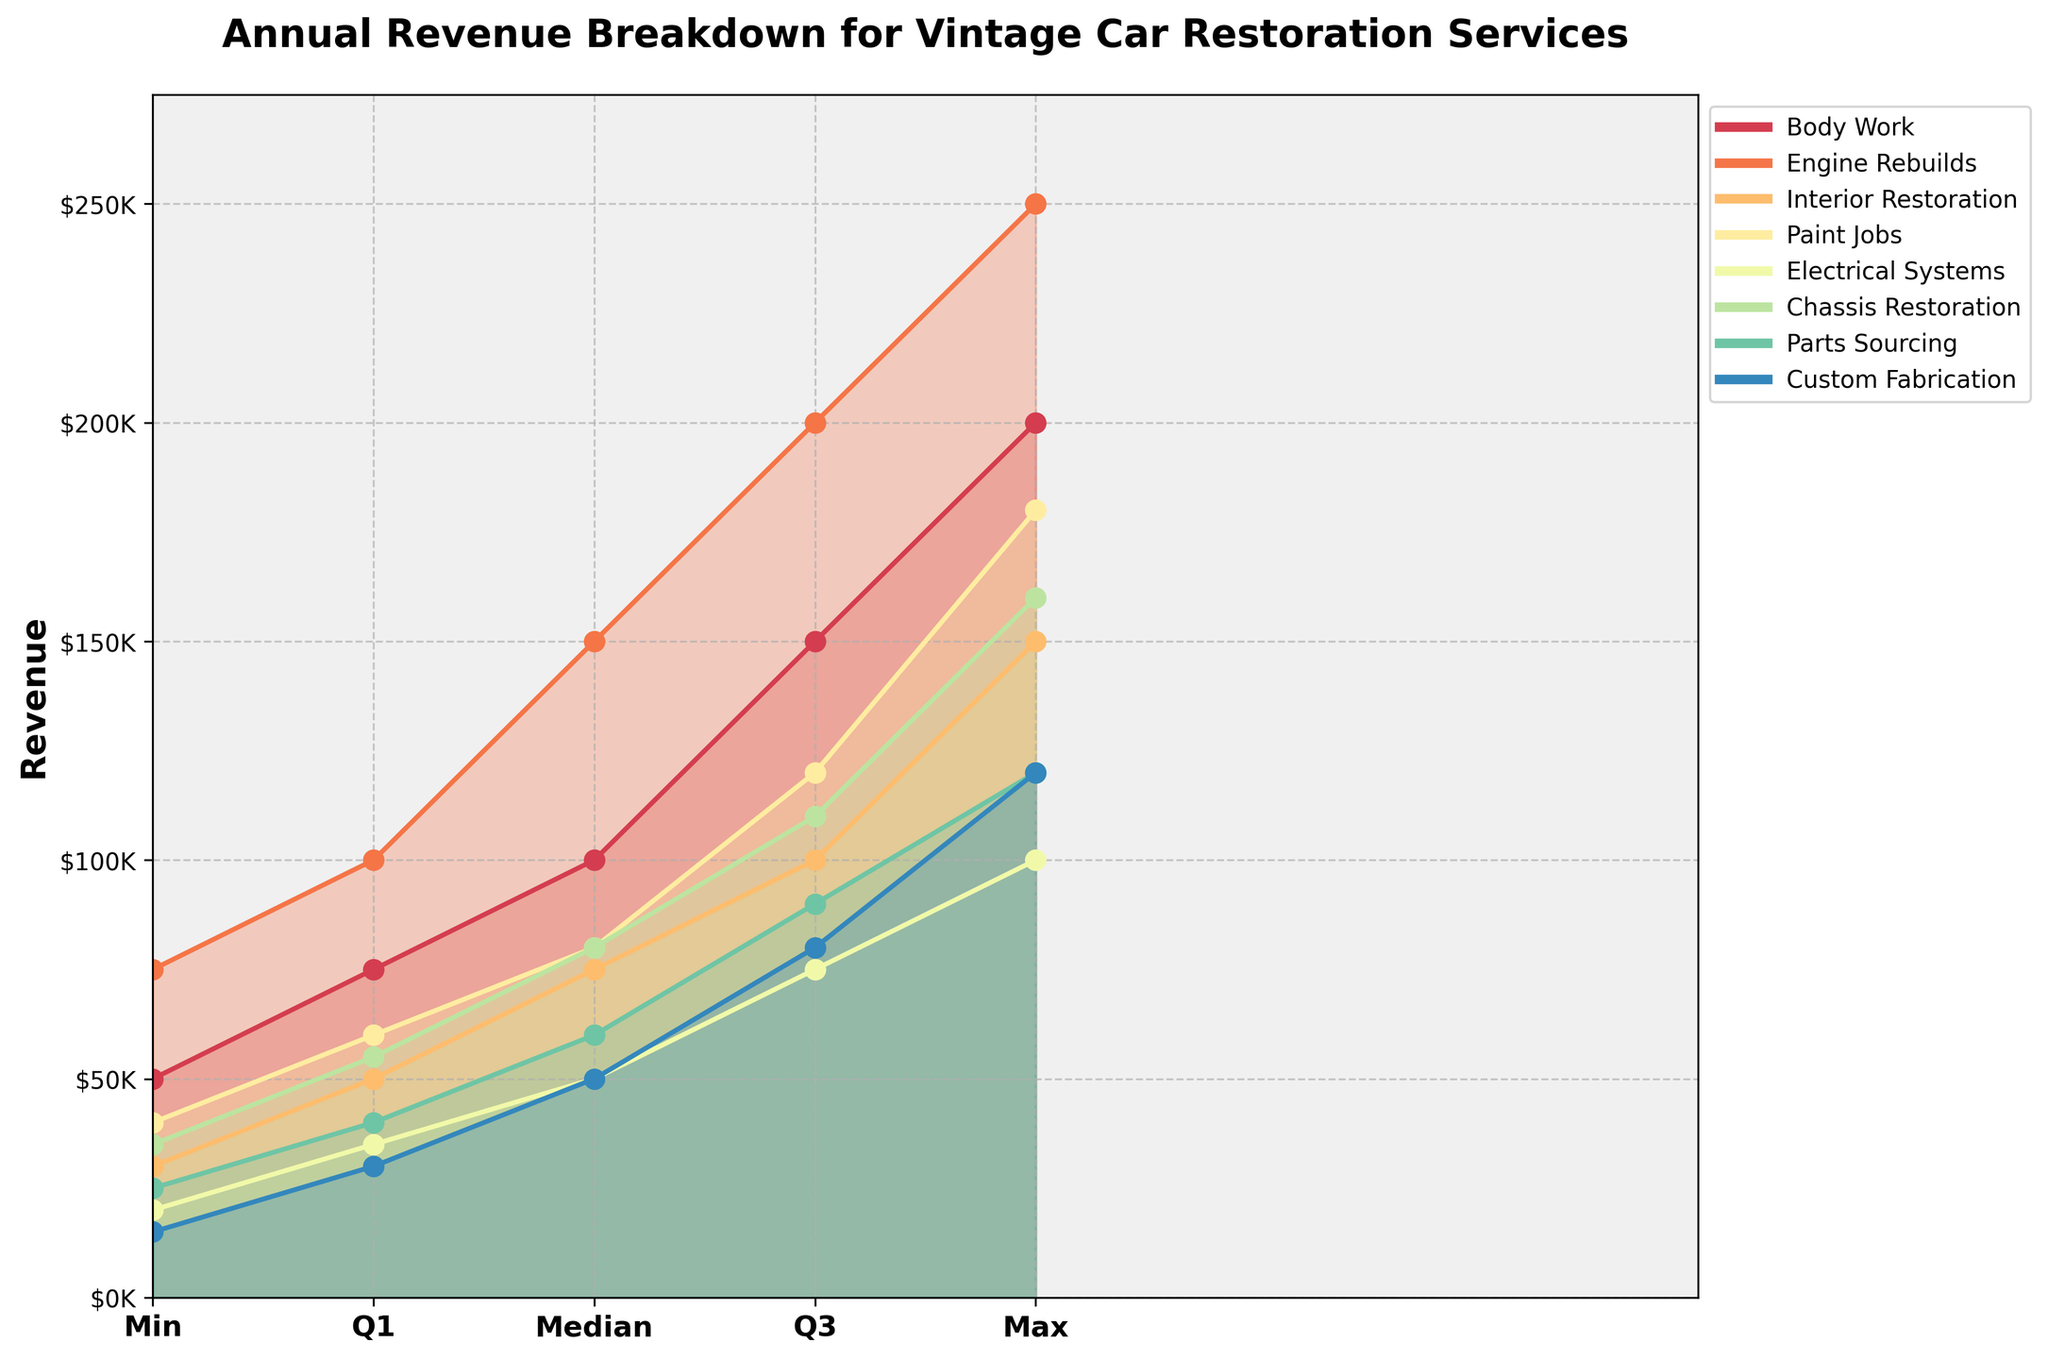How many service categories are represented in the figure? The figure includes different colored segments representing each service category. Counting the unique colors indicates the number of categories. There are eight distinct colors representing eight service categories.
Answer: 8 What is the median annual revenue for Engine Rebuilds? Locate the Engine Rebuilds category and find the line corresponding to the median value within the fan chart. The median value for Engine Rebuilds is labeled.
Answer: $150,000 Which service category has the lowest maximum annual revenue? Compare the endpoints of the fan charts (representing maximum values) to identify the one with the lowest position. Parts Sourcing has the lowest maximum annual revenue.
Answer: Parts Sourcing What is the difference between the maximum and minimum revenue for Paint Jobs? Find the maximum and minimum values for the Paint Jobs category from the figure and subtract the minimum from the maximum. Max is $180,000, and Min is $40,000, so the difference is $140,000.
Answer: $140,000 Which category has the highest revenue in the lower quartile? Compare the lower quartile points across all categories. Engine Rebuilds has the highest value at the lower quartile.
Answer: Engine Rebuilds What are the minimum and maximum revenues for Chassis Restoration? Identify the minimum and maximum points for the Chassis Restoration category from the figure. The minimum is $35,000, and the maximum is $160,000.
Answer: $35,000 and $160,000 Is the median revenue for Interior Restoration greater than the upper quartile for Electrical Systems? Locate the median value for Interior Restoration and the upper quartile for Electrical Systems and compare them. Interior Restoration (median $75,000) is greater than Electrical Systems (upper quartile $75,000).
Answer: No How does the revenue range for Custom Fabrication compare to that for Body Work? Calculate the range (max - min) for both categories and compare. Body Work ranges from $50,000 to $200,000 (range $150,000), Custom Fabrication ranges from $15,000 to $120,000 (range $105,000).
Answer: Body Work has a larger range Which category has the greatest spread between the upper quartile and the minimum value? Calculate the spread (upper quartile - minimum) for all categories. Body Work has the greatest spread, $150,000 - $50,000 = $100,000.
Answer: Body Work 